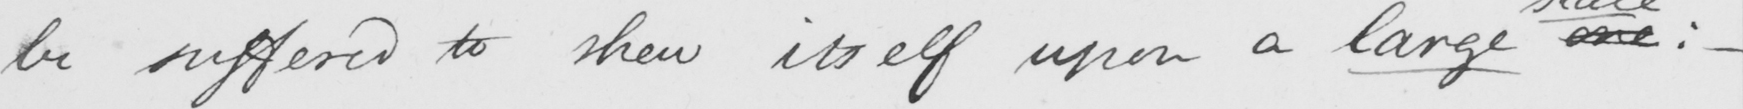What does this handwritten line say? be suffered to shew itself upon a large one  :   _ 